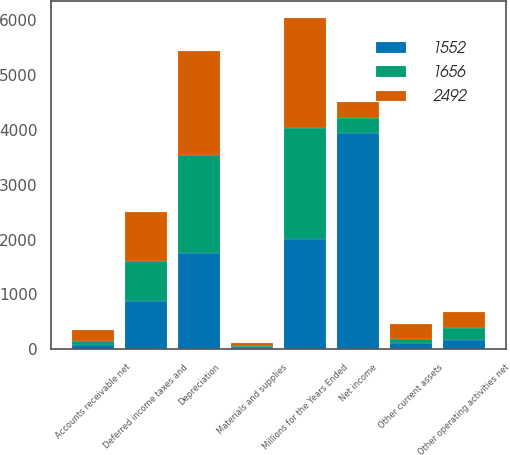Convert chart. <chart><loc_0><loc_0><loc_500><loc_500><stacked_bar_chart><ecel><fcel>Millions for the Years Ended<fcel>Net income<fcel>Depreciation<fcel>Deferred income taxes and<fcel>Other operating activities net<fcel>Accounts receivable net<fcel>Materials and supplies<fcel>Other current assets<nl><fcel>2492<fcel>2014<fcel>277.5<fcel>1904<fcel>895<fcel>285<fcel>197<fcel>59<fcel>270<nl><fcel>1656<fcel>2013<fcel>277.5<fcel>1777<fcel>723<fcel>226<fcel>83<fcel>7<fcel>74<nl><fcel>1552<fcel>2012<fcel>3943<fcel>1760<fcel>887<fcel>160<fcel>70<fcel>46<fcel>108<nl></chart> 